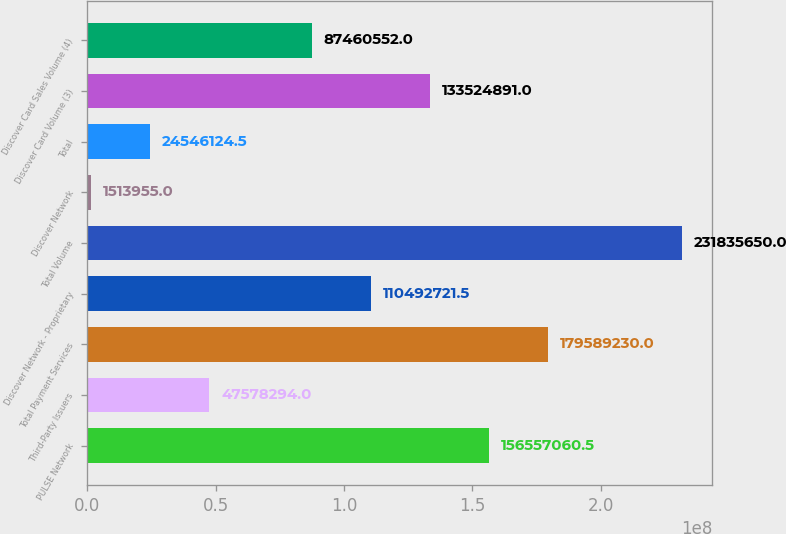Convert chart to OTSL. <chart><loc_0><loc_0><loc_500><loc_500><bar_chart><fcel>PULSE Network<fcel>Third-Party Issuers<fcel>Total Payment Services<fcel>Discover Network - Proprietary<fcel>Total Volume<fcel>Discover Network<fcel>Total<fcel>Discover Card Volume (3)<fcel>Discover Card Sales Volume (4)<nl><fcel>1.56557e+08<fcel>4.75783e+07<fcel>1.79589e+08<fcel>1.10493e+08<fcel>2.31836e+08<fcel>1.51396e+06<fcel>2.45461e+07<fcel>1.33525e+08<fcel>8.74606e+07<nl></chart> 